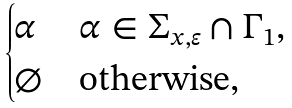<formula> <loc_0><loc_0><loc_500><loc_500>\begin{cases} \alpha & \alpha \in \Sigma _ { x , \varepsilon } \cap \Gamma _ { 1 } , \\ \varnothing & \text {otherwise} , \end{cases}</formula> 